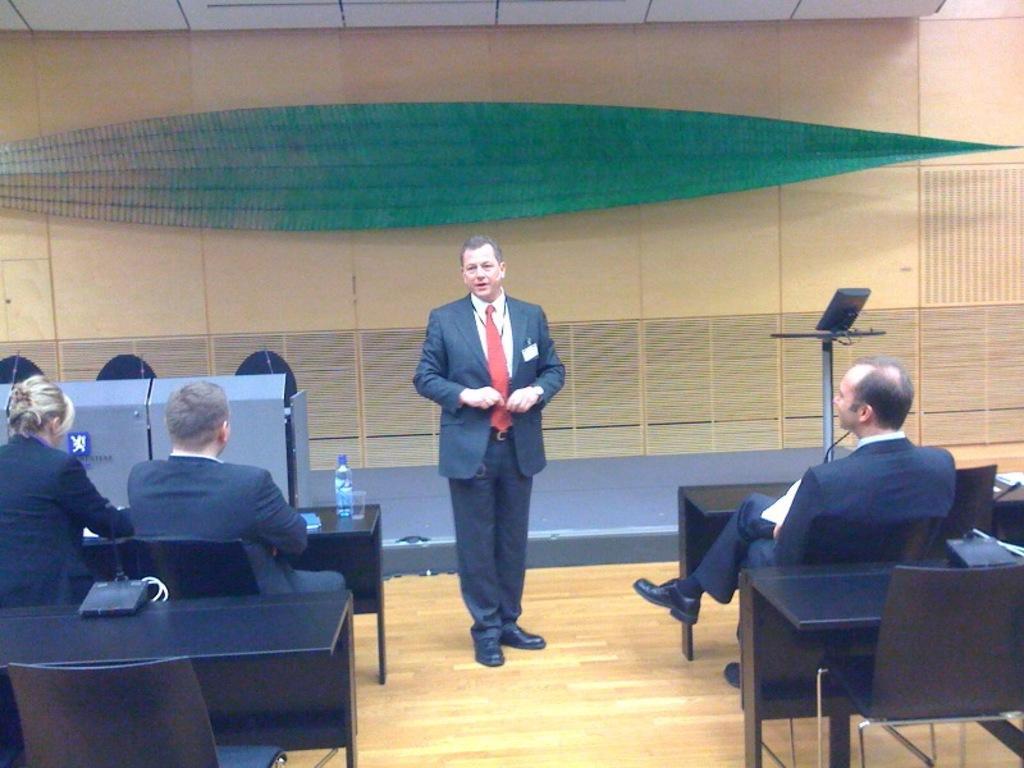Describe this image in one or two sentences. In this picture we can see one man wearing a blue blazer and talking something. Here we can see few persons sitting on chairs in front of a table. On the table we can see a glass and a bottle. This is a floor. 